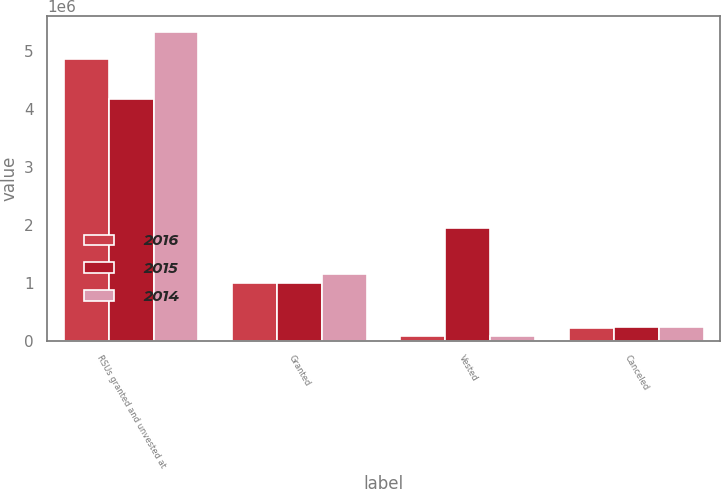<chart> <loc_0><loc_0><loc_500><loc_500><stacked_bar_chart><ecel><fcel>RSUs granted and unvested at<fcel>Granted<fcel>Vested<fcel>Canceled<nl><fcel>2016<fcel>4.8621e+06<fcel>1.00056e+06<fcel>77250<fcel>219536<nl><fcel>2015<fcel>4.15832e+06<fcel>997522<fcel>1.938e+06<fcel>231642<nl><fcel>2014<fcel>5.33044e+06<fcel>1.15495e+06<fcel>81500<fcel>234525<nl></chart> 